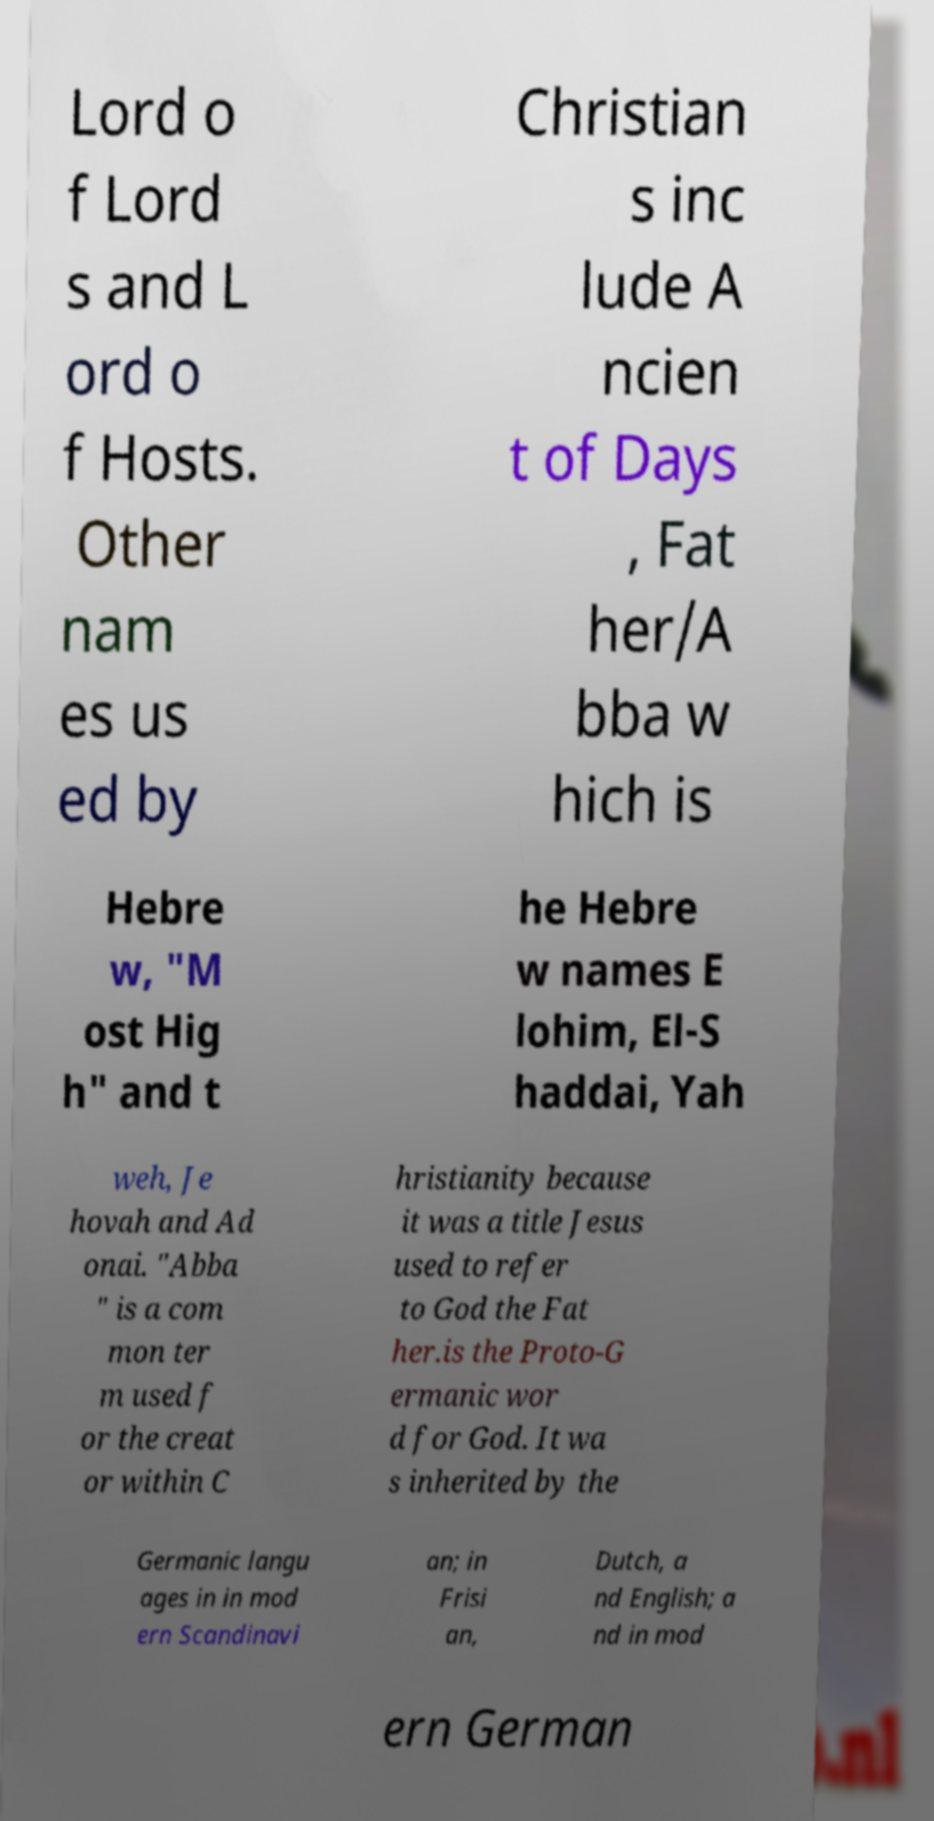Please read and relay the text visible in this image. What does it say? Lord o f Lord s and L ord o f Hosts. Other nam es us ed by Christian s inc lude A ncien t of Days , Fat her/A bba w hich is Hebre w, "M ost Hig h" and t he Hebre w names E lohim, El-S haddai, Yah weh, Je hovah and Ad onai. "Abba " is a com mon ter m used f or the creat or within C hristianity because it was a title Jesus used to refer to God the Fat her.is the Proto-G ermanic wor d for God. It wa s inherited by the Germanic langu ages in in mod ern Scandinavi an; in Frisi an, Dutch, a nd English; a nd in mod ern German 